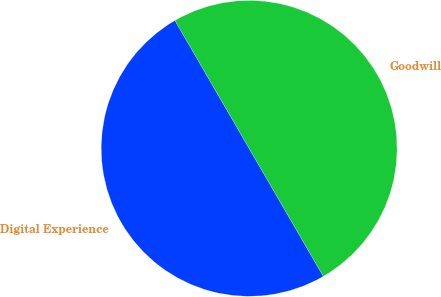Convert chart to OTSL. <chart><loc_0><loc_0><loc_500><loc_500><pie_chart><fcel>Digital Experience<fcel>Goodwill<nl><fcel>50.0%<fcel>50.0%<nl></chart> 